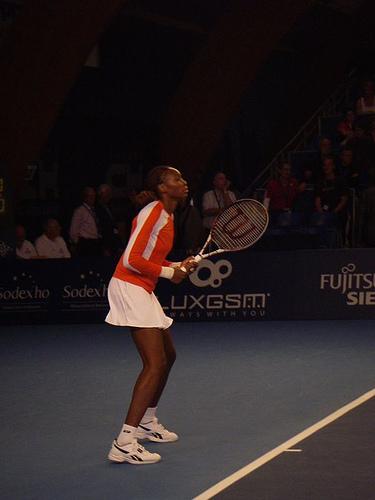How many women are in this scene?
Write a very short answer. 1. Is the weather hot?
Write a very short answer. No. What sport is she dressed for?
Quick response, please. Tennis. What brand of shoes is he wearing?
Keep it brief. Adidas. What is the person standing on?
Write a very short answer. Court. Is the camera angled high or low?
Concise answer only. Low. Are the socks worn high?
Short answer required. No. What are the shapes on the strings of her tennis racquet?
Short answer required. Squares. What color are her pants?
Short answer required. White. What is the letter on her racquet?
Give a very brief answer. W. Is this a real person?
Write a very short answer. Yes. Is this an outdoor match?
Concise answer only. No. 